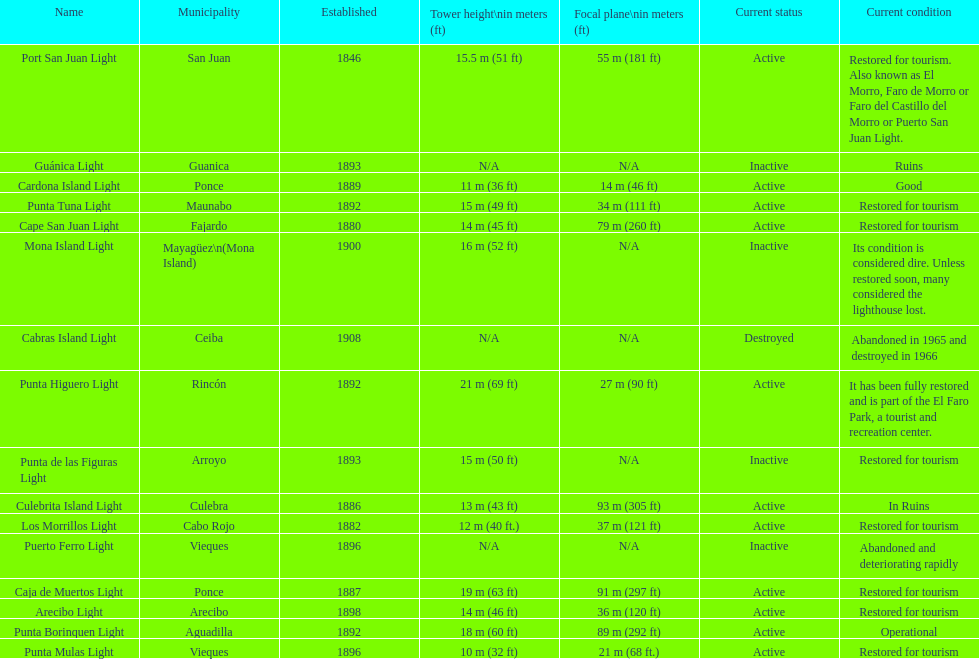The difference in years from 1882 to 1889 7. 